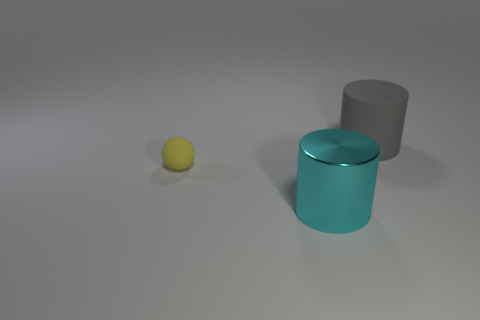Subtract all cyan cylinders. How many cylinders are left? 1 Add 1 large cyan cylinders. How many objects exist? 4 Subtract all cylinders. How many objects are left? 1 Subtract 0 green cylinders. How many objects are left? 3 Subtract all cyan cylinders. Subtract all yellow balls. How many cylinders are left? 1 Subtract all green cylinders. How many gray spheres are left? 0 Subtract all large blue objects. Subtract all tiny balls. How many objects are left? 2 Add 3 large cyan shiny objects. How many large cyan shiny objects are left? 4 Add 1 big cyan metallic things. How many big cyan metallic things exist? 2 